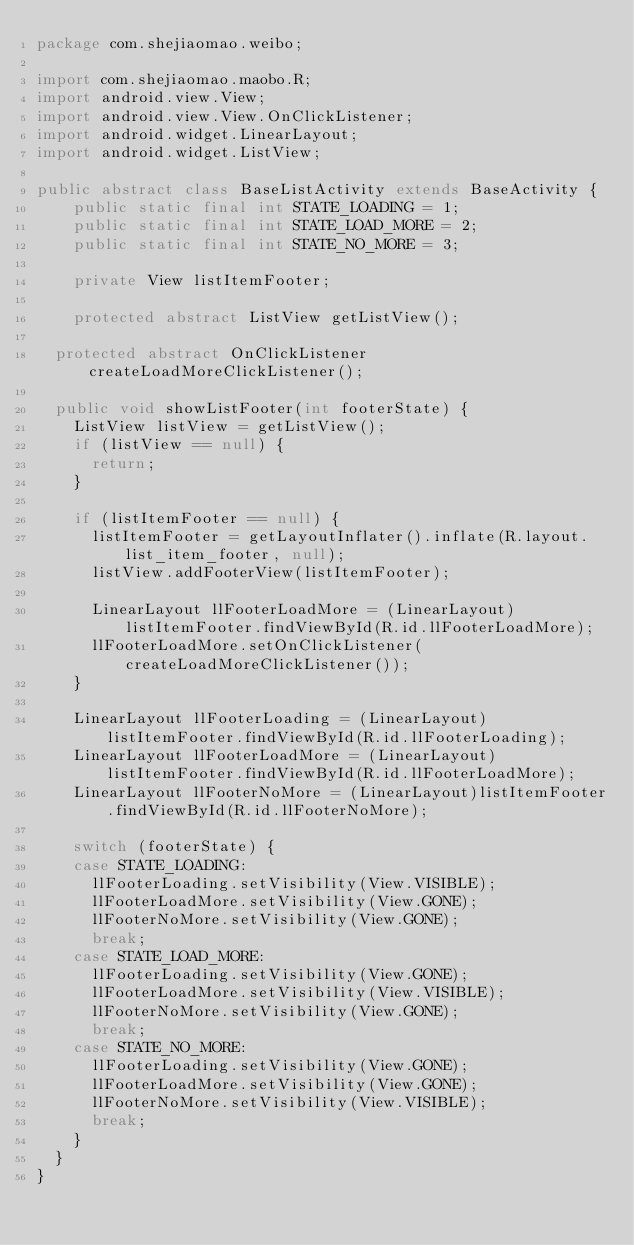<code> <loc_0><loc_0><loc_500><loc_500><_Java_>package com.shejiaomao.weibo;

import com.shejiaomao.maobo.R;
import android.view.View;
import android.view.View.OnClickListener;
import android.widget.LinearLayout;
import android.widget.ListView;

public abstract class BaseListActivity extends BaseActivity {
    public static final int STATE_LOADING = 1;
    public static final int STATE_LOAD_MORE = 2;
    public static final int STATE_NO_MORE = 3;
    
    private View listItemFooter;
    
    protected abstract ListView getListView();
    
	protected abstract OnClickListener createLoadMoreClickListener();
	
	public void showListFooter(int footerState) {
		ListView listView = getListView();
		if (listView == null) {
			return;
		}
		
		if (listItemFooter == null) {
			listItemFooter = getLayoutInflater().inflate(R.layout.list_item_footer, null);			
			listView.addFooterView(listItemFooter);
			
			LinearLayout llFooterLoadMore = (LinearLayout)listItemFooter.findViewById(R.id.llFooterLoadMore);
			llFooterLoadMore.setOnClickListener(createLoadMoreClickListener());
		}
		
		LinearLayout llFooterLoading = (LinearLayout)listItemFooter.findViewById(R.id.llFooterLoading);
		LinearLayout llFooterLoadMore = (LinearLayout)listItemFooter.findViewById(R.id.llFooterLoadMore);
		LinearLayout llFooterNoMore = (LinearLayout)listItemFooter.findViewById(R.id.llFooterNoMore);
		
		switch (footerState) {
		case STATE_LOADING:
			llFooterLoading.setVisibility(View.VISIBLE);
			llFooterLoadMore.setVisibility(View.GONE);
			llFooterNoMore.setVisibility(View.GONE);
			break;
		case STATE_LOAD_MORE:
			llFooterLoading.setVisibility(View.GONE);
			llFooterLoadMore.setVisibility(View.VISIBLE);
			llFooterNoMore.setVisibility(View.GONE);
			break;
		case STATE_NO_MORE:
			llFooterLoading.setVisibility(View.GONE);
			llFooterLoadMore.setVisibility(View.GONE);
			llFooterNoMore.setVisibility(View.VISIBLE);
			break;
		}
	}
}
</code> 